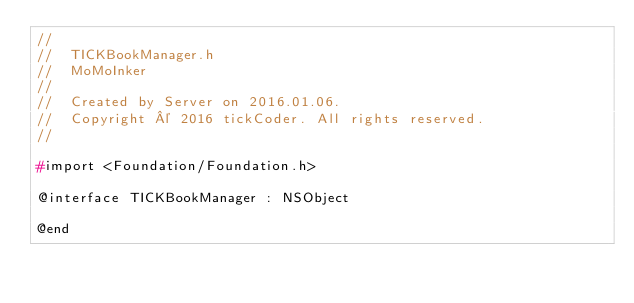Convert code to text. <code><loc_0><loc_0><loc_500><loc_500><_C_>//
//  TICKBookManager.h
//  MoMoInker
//
//  Created by Server on 2016.01.06.
//  Copyright © 2016 tickCoder. All rights reserved.
//

#import <Foundation/Foundation.h>

@interface TICKBookManager : NSObject

@end
</code> 